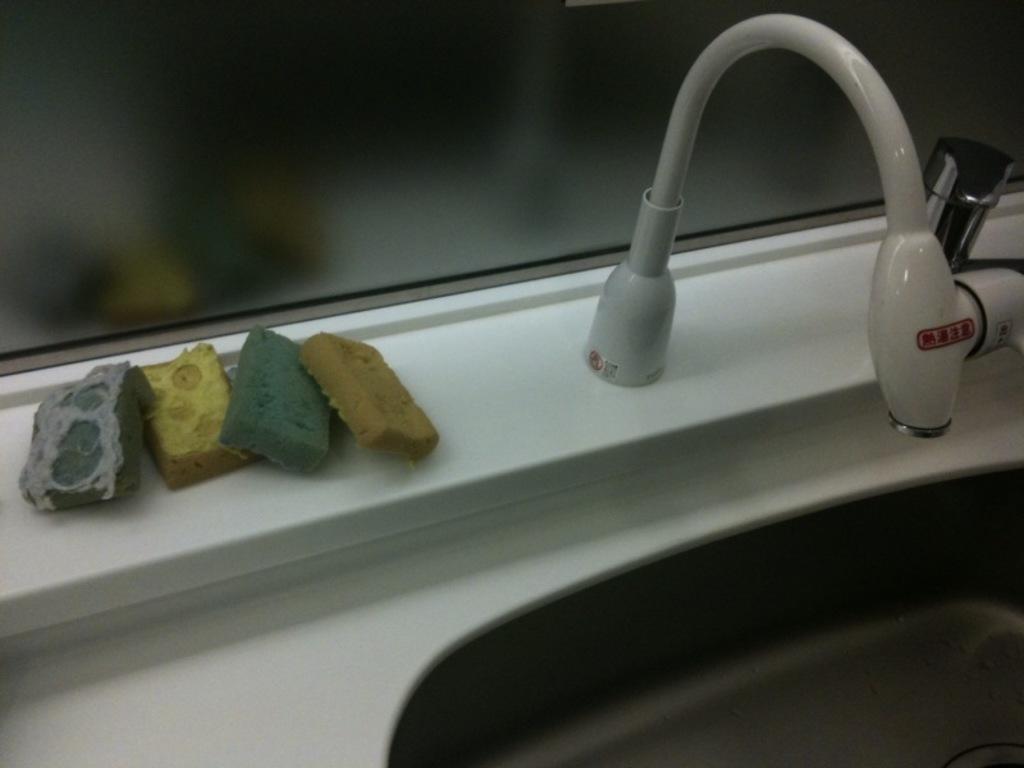Describe this image in one or two sentences. There is a sink, tap and few objects in the image. 